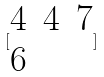Convert formula to latex. <formula><loc_0><loc_0><loc_500><loc_500>[ \begin{matrix} 4 & 4 & 7 \\ 6 \end{matrix} ]</formula> 